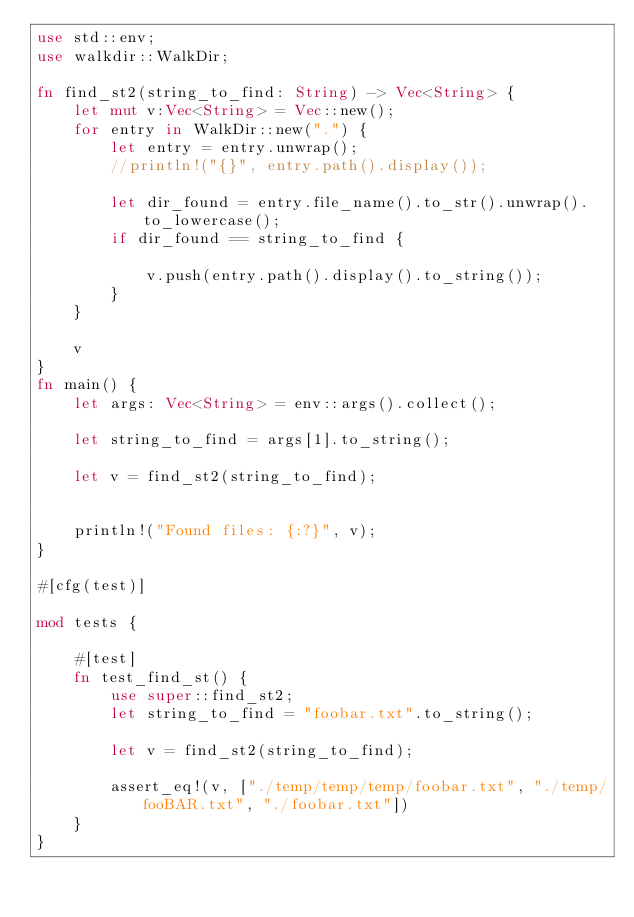Convert code to text. <code><loc_0><loc_0><loc_500><loc_500><_Rust_>use std::env;
use walkdir::WalkDir;

fn find_st2(string_to_find: String) -> Vec<String> {
    let mut v:Vec<String> = Vec::new();
    for entry in WalkDir::new(".") {
        let entry = entry.unwrap();
        //println!("{}", entry.path().display());

        let dir_found = entry.file_name().to_str().unwrap().to_lowercase();
        if dir_found == string_to_find {

            v.push(entry.path().display().to_string());
        }
    }

    v
}
fn main() {
    let args: Vec<String> = env::args().collect();

    let string_to_find = args[1].to_string();

    let v = find_st2(string_to_find);


    println!("Found files: {:?}", v);
}

#[cfg(test)]

mod tests {

    #[test]
    fn test_find_st() {
        use super::find_st2;
        let string_to_find = "foobar.txt".to_string();

        let v = find_st2(string_to_find);

        assert_eq!(v, ["./temp/temp/temp/foobar.txt", "./temp/fooBAR.txt", "./foobar.txt"])
    }
}
</code> 